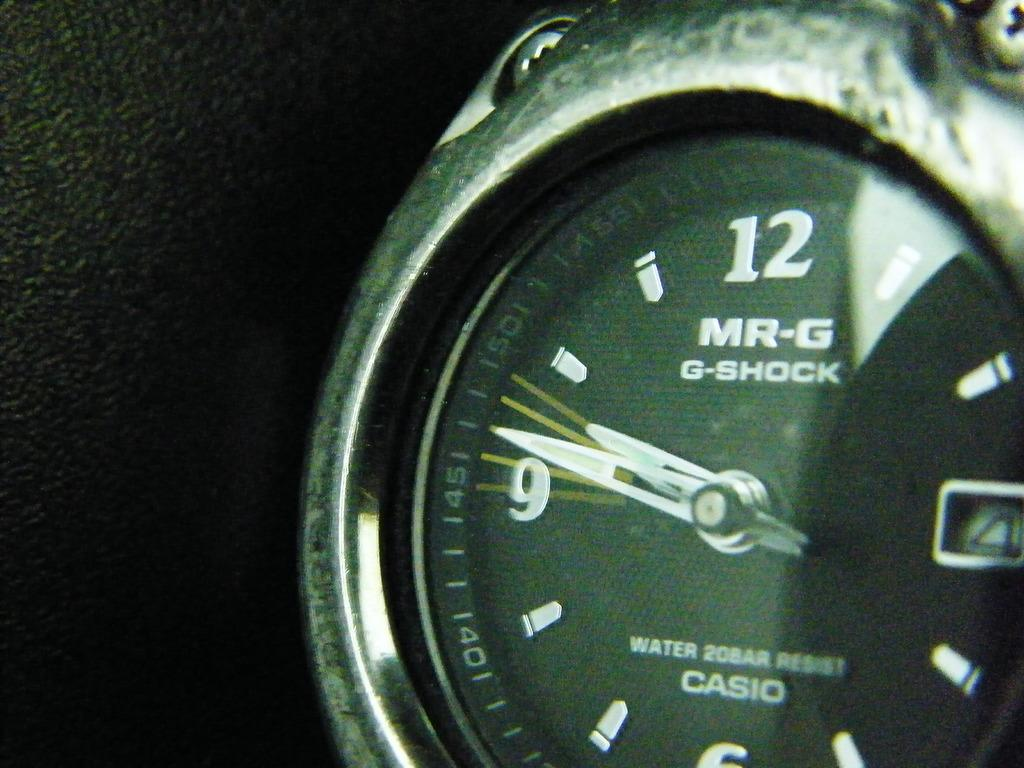<image>
Render a clear and concise summary of the photo. Close-up of the face of a MR-G G-Shock watch 